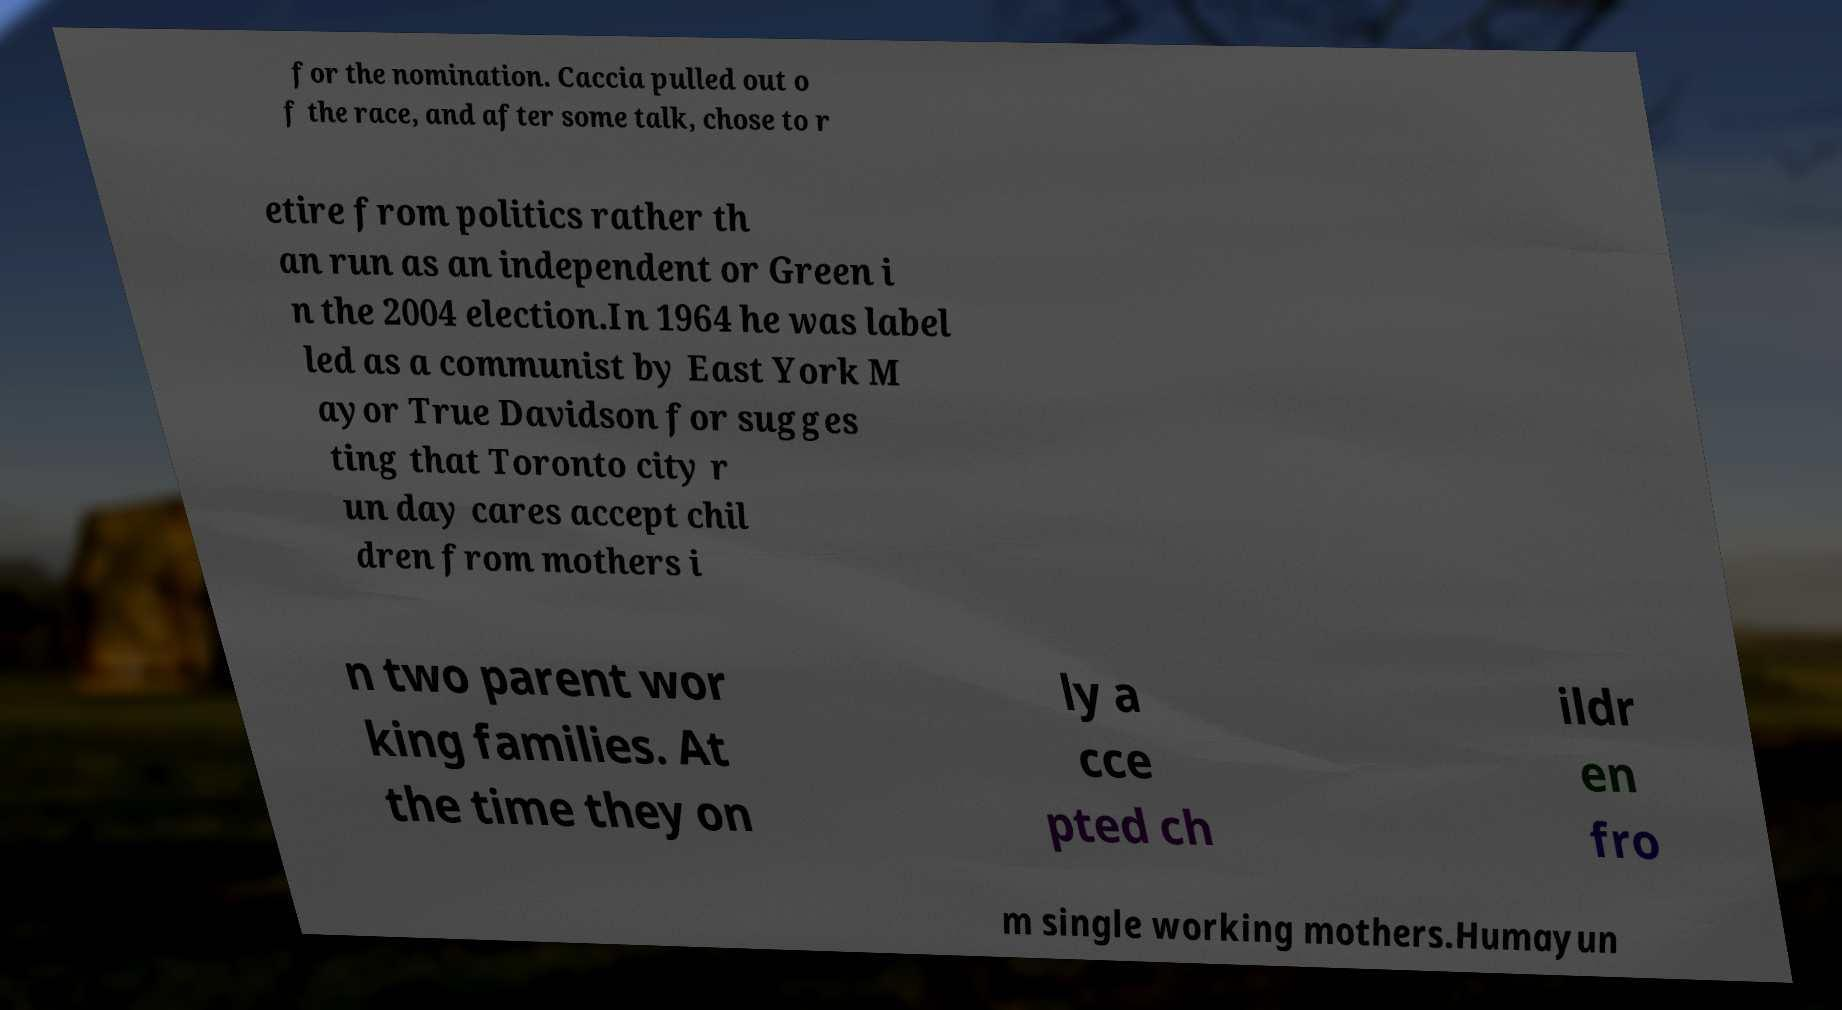Can you read and provide the text displayed in the image?This photo seems to have some interesting text. Can you extract and type it out for me? for the nomination. Caccia pulled out o f the race, and after some talk, chose to r etire from politics rather th an run as an independent or Green i n the 2004 election.In 1964 he was label led as a communist by East York M ayor True Davidson for sugges ting that Toronto city r un day cares accept chil dren from mothers i n two parent wor king families. At the time they on ly a cce pted ch ildr en fro m single working mothers.Humayun 